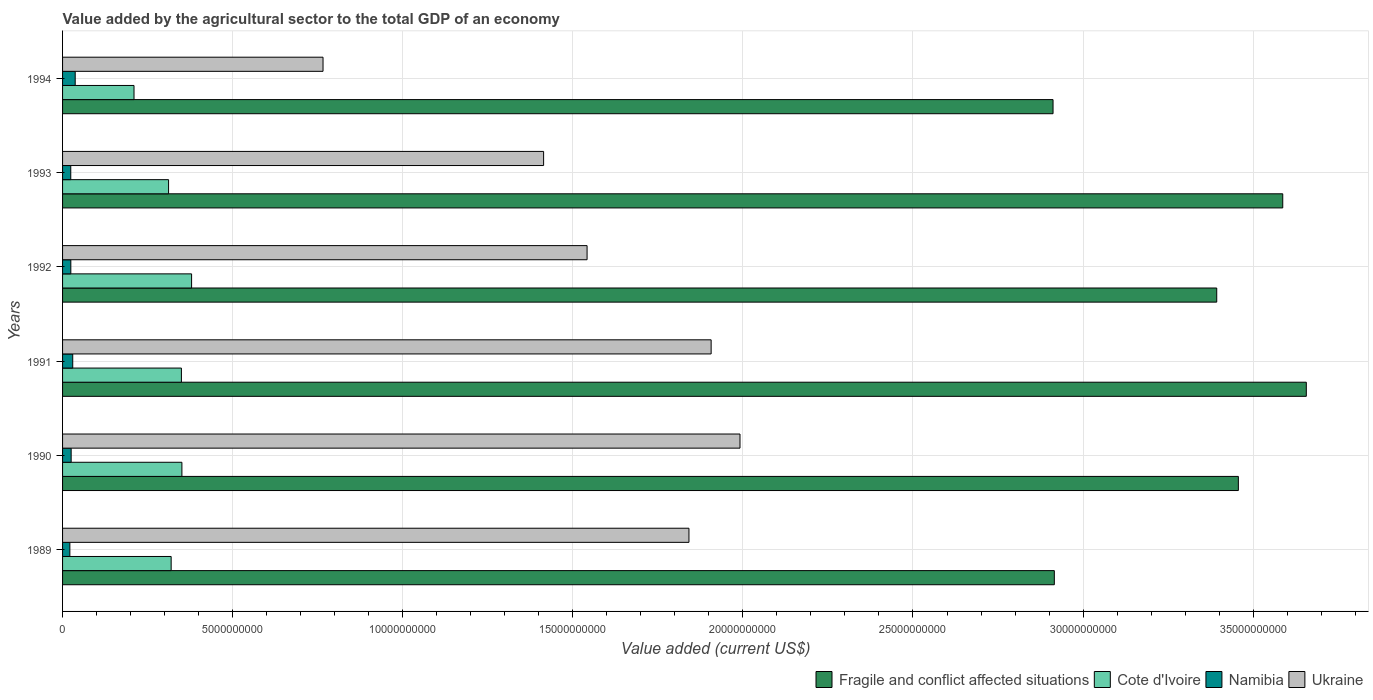How many different coloured bars are there?
Keep it short and to the point. 4. How many groups of bars are there?
Keep it short and to the point. 6. How many bars are there on the 4th tick from the top?
Your answer should be very brief. 4. In how many cases, is the number of bars for a given year not equal to the number of legend labels?
Offer a terse response. 0. What is the value added by the agricultural sector to the total GDP in Cote d'Ivoire in 1990?
Your answer should be very brief. 3.51e+09. Across all years, what is the maximum value added by the agricultural sector to the total GDP in Ukraine?
Give a very brief answer. 1.99e+1. Across all years, what is the minimum value added by the agricultural sector to the total GDP in Cote d'Ivoire?
Your answer should be very brief. 2.10e+09. What is the total value added by the agricultural sector to the total GDP in Fragile and conflict affected situations in the graph?
Give a very brief answer. 1.99e+11. What is the difference between the value added by the agricultural sector to the total GDP in Namibia in 1991 and that in 1992?
Give a very brief answer. 5.60e+07. What is the difference between the value added by the agricultural sector to the total GDP in Namibia in 1993 and the value added by the agricultural sector to the total GDP in Ukraine in 1989?
Give a very brief answer. -1.82e+1. What is the average value added by the agricultural sector to the total GDP in Ukraine per year?
Offer a terse response. 1.58e+1. In the year 1994, what is the difference between the value added by the agricultural sector to the total GDP in Cote d'Ivoire and value added by the agricultural sector to the total GDP in Namibia?
Your answer should be very brief. 1.73e+09. In how many years, is the value added by the agricultural sector to the total GDP in Ukraine greater than 11000000000 US$?
Make the answer very short. 5. What is the ratio of the value added by the agricultural sector to the total GDP in Cote d'Ivoire in 1990 to that in 1994?
Provide a succinct answer. 1.67. Is the value added by the agricultural sector to the total GDP in Cote d'Ivoire in 1989 less than that in 1994?
Your answer should be very brief. No. Is the difference between the value added by the agricultural sector to the total GDP in Cote d'Ivoire in 1991 and 1994 greater than the difference between the value added by the agricultural sector to the total GDP in Namibia in 1991 and 1994?
Provide a succinct answer. Yes. What is the difference between the highest and the second highest value added by the agricultural sector to the total GDP in Cote d'Ivoire?
Your answer should be very brief. 2.85e+08. What is the difference between the highest and the lowest value added by the agricultural sector to the total GDP in Cote d'Ivoire?
Provide a succinct answer. 1.69e+09. In how many years, is the value added by the agricultural sector to the total GDP in Cote d'Ivoire greater than the average value added by the agricultural sector to the total GDP in Cote d'Ivoire taken over all years?
Provide a succinct answer. 3. Is it the case that in every year, the sum of the value added by the agricultural sector to the total GDP in Cote d'Ivoire and value added by the agricultural sector to the total GDP in Namibia is greater than the sum of value added by the agricultural sector to the total GDP in Ukraine and value added by the agricultural sector to the total GDP in Fragile and conflict affected situations?
Keep it short and to the point. Yes. What does the 4th bar from the top in 1989 represents?
Keep it short and to the point. Fragile and conflict affected situations. What does the 2nd bar from the bottom in 1989 represents?
Provide a succinct answer. Cote d'Ivoire. What is the difference between two consecutive major ticks on the X-axis?
Keep it short and to the point. 5.00e+09. Are the values on the major ticks of X-axis written in scientific E-notation?
Make the answer very short. No. Does the graph contain grids?
Offer a terse response. Yes. Where does the legend appear in the graph?
Make the answer very short. Bottom right. How are the legend labels stacked?
Your answer should be very brief. Horizontal. What is the title of the graph?
Provide a succinct answer. Value added by the agricultural sector to the total GDP of an economy. What is the label or title of the X-axis?
Your response must be concise. Value added (current US$). What is the Value added (current US$) in Fragile and conflict affected situations in 1989?
Offer a terse response. 2.92e+1. What is the Value added (current US$) of Cote d'Ivoire in 1989?
Your answer should be compact. 3.19e+09. What is the Value added (current US$) of Namibia in 1989?
Your answer should be very brief. 2.14e+08. What is the Value added (current US$) of Ukraine in 1989?
Your response must be concise. 1.84e+1. What is the Value added (current US$) in Fragile and conflict affected situations in 1990?
Make the answer very short. 3.46e+1. What is the Value added (current US$) of Cote d'Ivoire in 1990?
Provide a succinct answer. 3.51e+09. What is the Value added (current US$) of Namibia in 1990?
Offer a very short reply. 2.53e+08. What is the Value added (current US$) of Ukraine in 1990?
Ensure brevity in your answer.  1.99e+1. What is the Value added (current US$) of Fragile and conflict affected situations in 1991?
Provide a short and direct response. 3.66e+1. What is the Value added (current US$) in Cote d'Ivoire in 1991?
Offer a terse response. 3.49e+09. What is the Value added (current US$) in Namibia in 1991?
Offer a very short reply. 2.99e+08. What is the Value added (current US$) in Ukraine in 1991?
Offer a very short reply. 1.91e+1. What is the Value added (current US$) in Fragile and conflict affected situations in 1992?
Provide a short and direct response. 3.39e+1. What is the Value added (current US$) in Cote d'Ivoire in 1992?
Your answer should be compact. 3.79e+09. What is the Value added (current US$) of Namibia in 1992?
Offer a terse response. 2.43e+08. What is the Value added (current US$) of Ukraine in 1992?
Offer a very short reply. 1.54e+1. What is the Value added (current US$) of Fragile and conflict affected situations in 1993?
Give a very brief answer. 3.59e+1. What is the Value added (current US$) in Cote d'Ivoire in 1993?
Give a very brief answer. 3.12e+09. What is the Value added (current US$) of Namibia in 1993?
Offer a very short reply. 2.41e+08. What is the Value added (current US$) of Ukraine in 1993?
Provide a succinct answer. 1.41e+1. What is the Value added (current US$) of Fragile and conflict affected situations in 1994?
Provide a short and direct response. 2.91e+1. What is the Value added (current US$) of Cote d'Ivoire in 1994?
Give a very brief answer. 2.10e+09. What is the Value added (current US$) of Namibia in 1994?
Ensure brevity in your answer.  3.71e+08. What is the Value added (current US$) of Ukraine in 1994?
Offer a very short reply. 7.66e+09. Across all years, what is the maximum Value added (current US$) in Fragile and conflict affected situations?
Provide a succinct answer. 3.66e+1. Across all years, what is the maximum Value added (current US$) of Cote d'Ivoire?
Offer a very short reply. 3.79e+09. Across all years, what is the maximum Value added (current US$) of Namibia?
Offer a very short reply. 3.71e+08. Across all years, what is the maximum Value added (current US$) in Ukraine?
Your answer should be very brief. 1.99e+1. Across all years, what is the minimum Value added (current US$) of Fragile and conflict affected situations?
Your response must be concise. 2.91e+1. Across all years, what is the minimum Value added (current US$) in Cote d'Ivoire?
Provide a short and direct response. 2.10e+09. Across all years, what is the minimum Value added (current US$) in Namibia?
Give a very brief answer. 2.14e+08. Across all years, what is the minimum Value added (current US$) in Ukraine?
Make the answer very short. 7.66e+09. What is the total Value added (current US$) in Fragile and conflict affected situations in the graph?
Give a very brief answer. 1.99e+11. What is the total Value added (current US$) of Cote d'Ivoire in the graph?
Your answer should be very brief. 1.92e+1. What is the total Value added (current US$) in Namibia in the graph?
Your answer should be compact. 1.62e+09. What is the total Value added (current US$) in Ukraine in the graph?
Ensure brevity in your answer.  9.46e+1. What is the difference between the Value added (current US$) in Fragile and conflict affected situations in 1989 and that in 1990?
Your response must be concise. -5.41e+09. What is the difference between the Value added (current US$) of Cote d'Ivoire in 1989 and that in 1990?
Keep it short and to the point. -3.16e+08. What is the difference between the Value added (current US$) of Namibia in 1989 and that in 1990?
Your answer should be very brief. -3.82e+07. What is the difference between the Value added (current US$) in Ukraine in 1989 and that in 1990?
Give a very brief answer. -1.50e+09. What is the difference between the Value added (current US$) in Fragile and conflict affected situations in 1989 and that in 1991?
Your answer should be compact. -7.41e+09. What is the difference between the Value added (current US$) of Cote d'Ivoire in 1989 and that in 1991?
Your answer should be very brief. -3.01e+08. What is the difference between the Value added (current US$) of Namibia in 1989 and that in 1991?
Provide a short and direct response. -8.45e+07. What is the difference between the Value added (current US$) of Ukraine in 1989 and that in 1991?
Your response must be concise. -6.52e+08. What is the difference between the Value added (current US$) of Fragile and conflict affected situations in 1989 and that in 1992?
Make the answer very short. -4.77e+09. What is the difference between the Value added (current US$) in Cote d'Ivoire in 1989 and that in 1992?
Keep it short and to the point. -6.01e+08. What is the difference between the Value added (current US$) of Namibia in 1989 and that in 1992?
Your response must be concise. -2.85e+07. What is the difference between the Value added (current US$) of Ukraine in 1989 and that in 1992?
Provide a short and direct response. 2.99e+09. What is the difference between the Value added (current US$) in Fragile and conflict affected situations in 1989 and that in 1993?
Keep it short and to the point. -6.71e+09. What is the difference between the Value added (current US$) in Cote d'Ivoire in 1989 and that in 1993?
Your response must be concise. 7.57e+07. What is the difference between the Value added (current US$) of Namibia in 1989 and that in 1993?
Provide a succinct answer. -2.68e+07. What is the difference between the Value added (current US$) in Ukraine in 1989 and that in 1993?
Offer a terse response. 4.27e+09. What is the difference between the Value added (current US$) of Fragile and conflict affected situations in 1989 and that in 1994?
Make the answer very short. 3.81e+07. What is the difference between the Value added (current US$) of Cote d'Ivoire in 1989 and that in 1994?
Offer a very short reply. 1.09e+09. What is the difference between the Value added (current US$) of Namibia in 1989 and that in 1994?
Provide a succinct answer. -1.57e+08. What is the difference between the Value added (current US$) in Ukraine in 1989 and that in 1994?
Ensure brevity in your answer.  1.08e+1. What is the difference between the Value added (current US$) in Fragile and conflict affected situations in 1990 and that in 1991?
Your answer should be very brief. -2.00e+09. What is the difference between the Value added (current US$) of Cote d'Ivoire in 1990 and that in 1991?
Your answer should be compact. 1.51e+07. What is the difference between the Value added (current US$) of Namibia in 1990 and that in 1991?
Offer a very short reply. -4.63e+07. What is the difference between the Value added (current US$) of Ukraine in 1990 and that in 1991?
Keep it short and to the point. 8.49e+08. What is the difference between the Value added (current US$) of Fragile and conflict affected situations in 1990 and that in 1992?
Ensure brevity in your answer.  6.36e+08. What is the difference between the Value added (current US$) in Cote d'Ivoire in 1990 and that in 1992?
Provide a short and direct response. -2.85e+08. What is the difference between the Value added (current US$) in Namibia in 1990 and that in 1992?
Your answer should be very brief. 9.72e+06. What is the difference between the Value added (current US$) of Ukraine in 1990 and that in 1992?
Offer a terse response. 4.50e+09. What is the difference between the Value added (current US$) of Fragile and conflict affected situations in 1990 and that in 1993?
Offer a terse response. -1.31e+09. What is the difference between the Value added (current US$) of Cote d'Ivoire in 1990 and that in 1993?
Give a very brief answer. 3.92e+08. What is the difference between the Value added (current US$) of Namibia in 1990 and that in 1993?
Your answer should be very brief. 1.14e+07. What is the difference between the Value added (current US$) in Ukraine in 1990 and that in 1993?
Provide a succinct answer. 5.77e+09. What is the difference between the Value added (current US$) in Fragile and conflict affected situations in 1990 and that in 1994?
Give a very brief answer. 5.45e+09. What is the difference between the Value added (current US$) in Cote d'Ivoire in 1990 and that in 1994?
Keep it short and to the point. 1.41e+09. What is the difference between the Value added (current US$) in Namibia in 1990 and that in 1994?
Your answer should be compact. -1.19e+08. What is the difference between the Value added (current US$) in Ukraine in 1990 and that in 1994?
Provide a short and direct response. 1.23e+1. What is the difference between the Value added (current US$) in Fragile and conflict affected situations in 1991 and that in 1992?
Provide a short and direct response. 2.63e+09. What is the difference between the Value added (current US$) of Cote d'Ivoire in 1991 and that in 1992?
Your answer should be very brief. -3.00e+08. What is the difference between the Value added (current US$) in Namibia in 1991 and that in 1992?
Your answer should be very brief. 5.60e+07. What is the difference between the Value added (current US$) of Ukraine in 1991 and that in 1992?
Give a very brief answer. 3.65e+09. What is the difference between the Value added (current US$) in Fragile and conflict affected situations in 1991 and that in 1993?
Your answer should be very brief. 6.92e+08. What is the difference between the Value added (current US$) of Cote d'Ivoire in 1991 and that in 1993?
Make the answer very short. 3.77e+08. What is the difference between the Value added (current US$) of Namibia in 1991 and that in 1993?
Offer a terse response. 5.76e+07. What is the difference between the Value added (current US$) of Ukraine in 1991 and that in 1993?
Give a very brief answer. 4.92e+09. What is the difference between the Value added (current US$) of Fragile and conflict affected situations in 1991 and that in 1994?
Your answer should be very brief. 7.45e+09. What is the difference between the Value added (current US$) of Cote d'Ivoire in 1991 and that in 1994?
Offer a terse response. 1.39e+09. What is the difference between the Value added (current US$) in Namibia in 1991 and that in 1994?
Provide a short and direct response. -7.25e+07. What is the difference between the Value added (current US$) in Ukraine in 1991 and that in 1994?
Offer a terse response. 1.14e+1. What is the difference between the Value added (current US$) of Fragile and conflict affected situations in 1992 and that in 1993?
Keep it short and to the point. -1.94e+09. What is the difference between the Value added (current US$) in Cote d'Ivoire in 1992 and that in 1993?
Keep it short and to the point. 6.77e+08. What is the difference between the Value added (current US$) of Namibia in 1992 and that in 1993?
Provide a succinct answer. 1.67e+06. What is the difference between the Value added (current US$) in Ukraine in 1992 and that in 1993?
Your answer should be very brief. 1.28e+09. What is the difference between the Value added (current US$) in Fragile and conflict affected situations in 1992 and that in 1994?
Provide a short and direct response. 4.81e+09. What is the difference between the Value added (current US$) of Cote d'Ivoire in 1992 and that in 1994?
Your answer should be compact. 1.69e+09. What is the difference between the Value added (current US$) in Namibia in 1992 and that in 1994?
Make the answer very short. -1.28e+08. What is the difference between the Value added (current US$) of Ukraine in 1992 and that in 1994?
Offer a terse response. 7.76e+09. What is the difference between the Value added (current US$) in Fragile and conflict affected situations in 1993 and that in 1994?
Provide a short and direct response. 6.75e+09. What is the difference between the Value added (current US$) in Cote d'Ivoire in 1993 and that in 1994?
Give a very brief answer. 1.02e+09. What is the difference between the Value added (current US$) of Namibia in 1993 and that in 1994?
Your answer should be very brief. -1.30e+08. What is the difference between the Value added (current US$) in Ukraine in 1993 and that in 1994?
Provide a succinct answer. 6.48e+09. What is the difference between the Value added (current US$) in Fragile and conflict affected situations in 1989 and the Value added (current US$) in Cote d'Ivoire in 1990?
Give a very brief answer. 2.56e+1. What is the difference between the Value added (current US$) in Fragile and conflict affected situations in 1989 and the Value added (current US$) in Namibia in 1990?
Your answer should be very brief. 2.89e+1. What is the difference between the Value added (current US$) in Fragile and conflict affected situations in 1989 and the Value added (current US$) in Ukraine in 1990?
Keep it short and to the point. 9.24e+09. What is the difference between the Value added (current US$) in Cote d'Ivoire in 1989 and the Value added (current US$) in Namibia in 1990?
Ensure brevity in your answer.  2.94e+09. What is the difference between the Value added (current US$) in Cote d'Ivoire in 1989 and the Value added (current US$) in Ukraine in 1990?
Your response must be concise. -1.67e+1. What is the difference between the Value added (current US$) in Namibia in 1989 and the Value added (current US$) in Ukraine in 1990?
Offer a terse response. -1.97e+1. What is the difference between the Value added (current US$) of Fragile and conflict affected situations in 1989 and the Value added (current US$) of Cote d'Ivoire in 1991?
Ensure brevity in your answer.  2.57e+1. What is the difference between the Value added (current US$) in Fragile and conflict affected situations in 1989 and the Value added (current US$) in Namibia in 1991?
Keep it short and to the point. 2.89e+1. What is the difference between the Value added (current US$) in Fragile and conflict affected situations in 1989 and the Value added (current US$) in Ukraine in 1991?
Keep it short and to the point. 1.01e+1. What is the difference between the Value added (current US$) in Cote d'Ivoire in 1989 and the Value added (current US$) in Namibia in 1991?
Provide a succinct answer. 2.89e+09. What is the difference between the Value added (current US$) of Cote d'Ivoire in 1989 and the Value added (current US$) of Ukraine in 1991?
Give a very brief answer. -1.59e+1. What is the difference between the Value added (current US$) of Namibia in 1989 and the Value added (current US$) of Ukraine in 1991?
Offer a very short reply. -1.89e+1. What is the difference between the Value added (current US$) of Fragile and conflict affected situations in 1989 and the Value added (current US$) of Cote d'Ivoire in 1992?
Provide a succinct answer. 2.54e+1. What is the difference between the Value added (current US$) in Fragile and conflict affected situations in 1989 and the Value added (current US$) in Namibia in 1992?
Your answer should be very brief. 2.89e+1. What is the difference between the Value added (current US$) of Fragile and conflict affected situations in 1989 and the Value added (current US$) of Ukraine in 1992?
Your answer should be compact. 1.37e+1. What is the difference between the Value added (current US$) of Cote d'Ivoire in 1989 and the Value added (current US$) of Namibia in 1992?
Your answer should be very brief. 2.95e+09. What is the difference between the Value added (current US$) in Cote d'Ivoire in 1989 and the Value added (current US$) in Ukraine in 1992?
Ensure brevity in your answer.  -1.22e+1. What is the difference between the Value added (current US$) in Namibia in 1989 and the Value added (current US$) in Ukraine in 1992?
Your answer should be very brief. -1.52e+1. What is the difference between the Value added (current US$) in Fragile and conflict affected situations in 1989 and the Value added (current US$) in Cote d'Ivoire in 1993?
Give a very brief answer. 2.60e+1. What is the difference between the Value added (current US$) in Fragile and conflict affected situations in 1989 and the Value added (current US$) in Namibia in 1993?
Give a very brief answer. 2.89e+1. What is the difference between the Value added (current US$) in Fragile and conflict affected situations in 1989 and the Value added (current US$) in Ukraine in 1993?
Your answer should be very brief. 1.50e+1. What is the difference between the Value added (current US$) of Cote d'Ivoire in 1989 and the Value added (current US$) of Namibia in 1993?
Your answer should be very brief. 2.95e+09. What is the difference between the Value added (current US$) of Cote d'Ivoire in 1989 and the Value added (current US$) of Ukraine in 1993?
Provide a short and direct response. -1.09e+1. What is the difference between the Value added (current US$) of Namibia in 1989 and the Value added (current US$) of Ukraine in 1993?
Keep it short and to the point. -1.39e+1. What is the difference between the Value added (current US$) of Fragile and conflict affected situations in 1989 and the Value added (current US$) of Cote d'Ivoire in 1994?
Give a very brief answer. 2.71e+1. What is the difference between the Value added (current US$) of Fragile and conflict affected situations in 1989 and the Value added (current US$) of Namibia in 1994?
Offer a very short reply. 2.88e+1. What is the difference between the Value added (current US$) in Fragile and conflict affected situations in 1989 and the Value added (current US$) in Ukraine in 1994?
Provide a succinct answer. 2.15e+1. What is the difference between the Value added (current US$) in Cote d'Ivoire in 1989 and the Value added (current US$) in Namibia in 1994?
Offer a very short reply. 2.82e+09. What is the difference between the Value added (current US$) of Cote d'Ivoire in 1989 and the Value added (current US$) of Ukraine in 1994?
Your response must be concise. -4.46e+09. What is the difference between the Value added (current US$) in Namibia in 1989 and the Value added (current US$) in Ukraine in 1994?
Provide a short and direct response. -7.44e+09. What is the difference between the Value added (current US$) in Fragile and conflict affected situations in 1990 and the Value added (current US$) in Cote d'Ivoire in 1991?
Give a very brief answer. 3.11e+1. What is the difference between the Value added (current US$) of Fragile and conflict affected situations in 1990 and the Value added (current US$) of Namibia in 1991?
Offer a terse response. 3.43e+1. What is the difference between the Value added (current US$) in Fragile and conflict affected situations in 1990 and the Value added (current US$) in Ukraine in 1991?
Make the answer very short. 1.55e+1. What is the difference between the Value added (current US$) in Cote d'Ivoire in 1990 and the Value added (current US$) in Namibia in 1991?
Give a very brief answer. 3.21e+09. What is the difference between the Value added (current US$) of Cote d'Ivoire in 1990 and the Value added (current US$) of Ukraine in 1991?
Your response must be concise. -1.56e+1. What is the difference between the Value added (current US$) of Namibia in 1990 and the Value added (current US$) of Ukraine in 1991?
Provide a succinct answer. -1.88e+1. What is the difference between the Value added (current US$) of Fragile and conflict affected situations in 1990 and the Value added (current US$) of Cote d'Ivoire in 1992?
Keep it short and to the point. 3.08e+1. What is the difference between the Value added (current US$) in Fragile and conflict affected situations in 1990 and the Value added (current US$) in Namibia in 1992?
Your answer should be very brief. 3.43e+1. What is the difference between the Value added (current US$) of Fragile and conflict affected situations in 1990 and the Value added (current US$) of Ukraine in 1992?
Keep it short and to the point. 1.91e+1. What is the difference between the Value added (current US$) in Cote d'Ivoire in 1990 and the Value added (current US$) in Namibia in 1992?
Provide a succinct answer. 3.27e+09. What is the difference between the Value added (current US$) in Cote d'Ivoire in 1990 and the Value added (current US$) in Ukraine in 1992?
Provide a short and direct response. -1.19e+1. What is the difference between the Value added (current US$) of Namibia in 1990 and the Value added (current US$) of Ukraine in 1992?
Give a very brief answer. -1.52e+1. What is the difference between the Value added (current US$) in Fragile and conflict affected situations in 1990 and the Value added (current US$) in Cote d'Ivoire in 1993?
Give a very brief answer. 3.14e+1. What is the difference between the Value added (current US$) in Fragile and conflict affected situations in 1990 and the Value added (current US$) in Namibia in 1993?
Your answer should be very brief. 3.43e+1. What is the difference between the Value added (current US$) of Fragile and conflict affected situations in 1990 and the Value added (current US$) of Ukraine in 1993?
Keep it short and to the point. 2.04e+1. What is the difference between the Value added (current US$) of Cote d'Ivoire in 1990 and the Value added (current US$) of Namibia in 1993?
Give a very brief answer. 3.27e+09. What is the difference between the Value added (current US$) of Cote d'Ivoire in 1990 and the Value added (current US$) of Ukraine in 1993?
Ensure brevity in your answer.  -1.06e+1. What is the difference between the Value added (current US$) of Namibia in 1990 and the Value added (current US$) of Ukraine in 1993?
Your answer should be very brief. -1.39e+1. What is the difference between the Value added (current US$) in Fragile and conflict affected situations in 1990 and the Value added (current US$) in Cote d'Ivoire in 1994?
Your answer should be very brief. 3.25e+1. What is the difference between the Value added (current US$) in Fragile and conflict affected situations in 1990 and the Value added (current US$) in Namibia in 1994?
Your answer should be very brief. 3.42e+1. What is the difference between the Value added (current US$) of Fragile and conflict affected situations in 1990 and the Value added (current US$) of Ukraine in 1994?
Ensure brevity in your answer.  2.69e+1. What is the difference between the Value added (current US$) of Cote d'Ivoire in 1990 and the Value added (current US$) of Namibia in 1994?
Your response must be concise. 3.14e+09. What is the difference between the Value added (current US$) of Cote d'Ivoire in 1990 and the Value added (current US$) of Ukraine in 1994?
Provide a succinct answer. -4.15e+09. What is the difference between the Value added (current US$) of Namibia in 1990 and the Value added (current US$) of Ukraine in 1994?
Make the answer very short. -7.40e+09. What is the difference between the Value added (current US$) in Fragile and conflict affected situations in 1991 and the Value added (current US$) in Cote d'Ivoire in 1992?
Provide a succinct answer. 3.28e+1. What is the difference between the Value added (current US$) of Fragile and conflict affected situations in 1991 and the Value added (current US$) of Namibia in 1992?
Your response must be concise. 3.63e+1. What is the difference between the Value added (current US$) in Fragile and conflict affected situations in 1991 and the Value added (current US$) in Ukraine in 1992?
Keep it short and to the point. 2.11e+1. What is the difference between the Value added (current US$) of Cote d'Ivoire in 1991 and the Value added (current US$) of Namibia in 1992?
Your answer should be compact. 3.25e+09. What is the difference between the Value added (current US$) of Cote d'Ivoire in 1991 and the Value added (current US$) of Ukraine in 1992?
Offer a terse response. -1.19e+1. What is the difference between the Value added (current US$) of Namibia in 1991 and the Value added (current US$) of Ukraine in 1992?
Your answer should be compact. -1.51e+1. What is the difference between the Value added (current US$) of Fragile and conflict affected situations in 1991 and the Value added (current US$) of Cote d'Ivoire in 1993?
Your response must be concise. 3.34e+1. What is the difference between the Value added (current US$) in Fragile and conflict affected situations in 1991 and the Value added (current US$) in Namibia in 1993?
Your answer should be compact. 3.63e+1. What is the difference between the Value added (current US$) of Fragile and conflict affected situations in 1991 and the Value added (current US$) of Ukraine in 1993?
Offer a very short reply. 2.24e+1. What is the difference between the Value added (current US$) of Cote d'Ivoire in 1991 and the Value added (current US$) of Namibia in 1993?
Ensure brevity in your answer.  3.25e+09. What is the difference between the Value added (current US$) of Cote d'Ivoire in 1991 and the Value added (current US$) of Ukraine in 1993?
Ensure brevity in your answer.  -1.06e+1. What is the difference between the Value added (current US$) of Namibia in 1991 and the Value added (current US$) of Ukraine in 1993?
Offer a terse response. -1.38e+1. What is the difference between the Value added (current US$) of Fragile and conflict affected situations in 1991 and the Value added (current US$) of Cote d'Ivoire in 1994?
Make the answer very short. 3.45e+1. What is the difference between the Value added (current US$) of Fragile and conflict affected situations in 1991 and the Value added (current US$) of Namibia in 1994?
Ensure brevity in your answer.  3.62e+1. What is the difference between the Value added (current US$) in Fragile and conflict affected situations in 1991 and the Value added (current US$) in Ukraine in 1994?
Your answer should be compact. 2.89e+1. What is the difference between the Value added (current US$) in Cote d'Ivoire in 1991 and the Value added (current US$) in Namibia in 1994?
Make the answer very short. 3.12e+09. What is the difference between the Value added (current US$) of Cote d'Ivoire in 1991 and the Value added (current US$) of Ukraine in 1994?
Give a very brief answer. -4.16e+09. What is the difference between the Value added (current US$) in Namibia in 1991 and the Value added (current US$) in Ukraine in 1994?
Your answer should be very brief. -7.36e+09. What is the difference between the Value added (current US$) in Fragile and conflict affected situations in 1992 and the Value added (current US$) in Cote d'Ivoire in 1993?
Ensure brevity in your answer.  3.08e+1. What is the difference between the Value added (current US$) in Fragile and conflict affected situations in 1992 and the Value added (current US$) in Namibia in 1993?
Offer a very short reply. 3.37e+1. What is the difference between the Value added (current US$) of Fragile and conflict affected situations in 1992 and the Value added (current US$) of Ukraine in 1993?
Your answer should be very brief. 1.98e+1. What is the difference between the Value added (current US$) of Cote d'Ivoire in 1992 and the Value added (current US$) of Namibia in 1993?
Provide a succinct answer. 3.55e+09. What is the difference between the Value added (current US$) of Cote d'Ivoire in 1992 and the Value added (current US$) of Ukraine in 1993?
Offer a very short reply. -1.03e+1. What is the difference between the Value added (current US$) in Namibia in 1992 and the Value added (current US$) in Ukraine in 1993?
Your answer should be very brief. -1.39e+1. What is the difference between the Value added (current US$) in Fragile and conflict affected situations in 1992 and the Value added (current US$) in Cote d'Ivoire in 1994?
Provide a succinct answer. 3.18e+1. What is the difference between the Value added (current US$) in Fragile and conflict affected situations in 1992 and the Value added (current US$) in Namibia in 1994?
Ensure brevity in your answer.  3.36e+1. What is the difference between the Value added (current US$) in Fragile and conflict affected situations in 1992 and the Value added (current US$) in Ukraine in 1994?
Offer a very short reply. 2.63e+1. What is the difference between the Value added (current US$) of Cote d'Ivoire in 1992 and the Value added (current US$) of Namibia in 1994?
Your answer should be compact. 3.42e+09. What is the difference between the Value added (current US$) of Cote d'Ivoire in 1992 and the Value added (current US$) of Ukraine in 1994?
Ensure brevity in your answer.  -3.86e+09. What is the difference between the Value added (current US$) of Namibia in 1992 and the Value added (current US$) of Ukraine in 1994?
Offer a very short reply. -7.41e+09. What is the difference between the Value added (current US$) in Fragile and conflict affected situations in 1993 and the Value added (current US$) in Cote d'Ivoire in 1994?
Keep it short and to the point. 3.38e+1. What is the difference between the Value added (current US$) in Fragile and conflict affected situations in 1993 and the Value added (current US$) in Namibia in 1994?
Offer a very short reply. 3.55e+1. What is the difference between the Value added (current US$) in Fragile and conflict affected situations in 1993 and the Value added (current US$) in Ukraine in 1994?
Give a very brief answer. 2.82e+1. What is the difference between the Value added (current US$) of Cote d'Ivoire in 1993 and the Value added (current US$) of Namibia in 1994?
Your answer should be very brief. 2.75e+09. What is the difference between the Value added (current US$) in Cote d'Ivoire in 1993 and the Value added (current US$) in Ukraine in 1994?
Ensure brevity in your answer.  -4.54e+09. What is the difference between the Value added (current US$) of Namibia in 1993 and the Value added (current US$) of Ukraine in 1994?
Provide a succinct answer. -7.42e+09. What is the average Value added (current US$) in Fragile and conflict affected situations per year?
Keep it short and to the point. 3.32e+1. What is the average Value added (current US$) in Cote d'Ivoire per year?
Give a very brief answer. 3.20e+09. What is the average Value added (current US$) of Namibia per year?
Your response must be concise. 2.70e+08. What is the average Value added (current US$) of Ukraine per year?
Your response must be concise. 1.58e+1. In the year 1989, what is the difference between the Value added (current US$) of Fragile and conflict affected situations and Value added (current US$) of Cote d'Ivoire?
Your answer should be compact. 2.60e+1. In the year 1989, what is the difference between the Value added (current US$) in Fragile and conflict affected situations and Value added (current US$) in Namibia?
Your answer should be compact. 2.89e+1. In the year 1989, what is the difference between the Value added (current US$) of Fragile and conflict affected situations and Value added (current US$) of Ukraine?
Offer a very short reply. 1.07e+1. In the year 1989, what is the difference between the Value added (current US$) of Cote d'Ivoire and Value added (current US$) of Namibia?
Offer a terse response. 2.98e+09. In the year 1989, what is the difference between the Value added (current US$) of Cote d'Ivoire and Value added (current US$) of Ukraine?
Ensure brevity in your answer.  -1.52e+1. In the year 1989, what is the difference between the Value added (current US$) in Namibia and Value added (current US$) in Ukraine?
Your response must be concise. -1.82e+1. In the year 1990, what is the difference between the Value added (current US$) in Fragile and conflict affected situations and Value added (current US$) in Cote d'Ivoire?
Keep it short and to the point. 3.11e+1. In the year 1990, what is the difference between the Value added (current US$) in Fragile and conflict affected situations and Value added (current US$) in Namibia?
Your answer should be very brief. 3.43e+1. In the year 1990, what is the difference between the Value added (current US$) in Fragile and conflict affected situations and Value added (current US$) in Ukraine?
Offer a very short reply. 1.47e+1. In the year 1990, what is the difference between the Value added (current US$) of Cote d'Ivoire and Value added (current US$) of Namibia?
Keep it short and to the point. 3.26e+09. In the year 1990, what is the difference between the Value added (current US$) in Cote d'Ivoire and Value added (current US$) in Ukraine?
Ensure brevity in your answer.  -1.64e+1. In the year 1990, what is the difference between the Value added (current US$) of Namibia and Value added (current US$) of Ukraine?
Provide a short and direct response. -1.97e+1. In the year 1991, what is the difference between the Value added (current US$) in Fragile and conflict affected situations and Value added (current US$) in Cote d'Ivoire?
Offer a terse response. 3.31e+1. In the year 1991, what is the difference between the Value added (current US$) of Fragile and conflict affected situations and Value added (current US$) of Namibia?
Provide a short and direct response. 3.63e+1. In the year 1991, what is the difference between the Value added (current US$) of Fragile and conflict affected situations and Value added (current US$) of Ukraine?
Your answer should be compact. 1.75e+1. In the year 1991, what is the difference between the Value added (current US$) in Cote d'Ivoire and Value added (current US$) in Namibia?
Your answer should be very brief. 3.19e+09. In the year 1991, what is the difference between the Value added (current US$) in Cote d'Ivoire and Value added (current US$) in Ukraine?
Your answer should be very brief. -1.56e+1. In the year 1991, what is the difference between the Value added (current US$) of Namibia and Value added (current US$) of Ukraine?
Make the answer very short. -1.88e+1. In the year 1992, what is the difference between the Value added (current US$) in Fragile and conflict affected situations and Value added (current US$) in Cote d'Ivoire?
Provide a succinct answer. 3.01e+1. In the year 1992, what is the difference between the Value added (current US$) in Fragile and conflict affected situations and Value added (current US$) in Namibia?
Provide a succinct answer. 3.37e+1. In the year 1992, what is the difference between the Value added (current US$) of Fragile and conflict affected situations and Value added (current US$) of Ukraine?
Provide a short and direct response. 1.85e+1. In the year 1992, what is the difference between the Value added (current US$) of Cote d'Ivoire and Value added (current US$) of Namibia?
Your answer should be compact. 3.55e+09. In the year 1992, what is the difference between the Value added (current US$) of Cote d'Ivoire and Value added (current US$) of Ukraine?
Provide a succinct answer. -1.16e+1. In the year 1992, what is the difference between the Value added (current US$) in Namibia and Value added (current US$) in Ukraine?
Give a very brief answer. -1.52e+1. In the year 1993, what is the difference between the Value added (current US$) of Fragile and conflict affected situations and Value added (current US$) of Cote d'Ivoire?
Ensure brevity in your answer.  3.28e+1. In the year 1993, what is the difference between the Value added (current US$) in Fragile and conflict affected situations and Value added (current US$) in Namibia?
Ensure brevity in your answer.  3.56e+1. In the year 1993, what is the difference between the Value added (current US$) of Fragile and conflict affected situations and Value added (current US$) of Ukraine?
Give a very brief answer. 2.17e+1. In the year 1993, what is the difference between the Value added (current US$) in Cote d'Ivoire and Value added (current US$) in Namibia?
Your response must be concise. 2.88e+09. In the year 1993, what is the difference between the Value added (current US$) in Cote d'Ivoire and Value added (current US$) in Ukraine?
Provide a succinct answer. -1.10e+1. In the year 1993, what is the difference between the Value added (current US$) of Namibia and Value added (current US$) of Ukraine?
Keep it short and to the point. -1.39e+1. In the year 1994, what is the difference between the Value added (current US$) in Fragile and conflict affected situations and Value added (current US$) in Cote d'Ivoire?
Your response must be concise. 2.70e+1. In the year 1994, what is the difference between the Value added (current US$) of Fragile and conflict affected situations and Value added (current US$) of Namibia?
Offer a terse response. 2.87e+1. In the year 1994, what is the difference between the Value added (current US$) of Fragile and conflict affected situations and Value added (current US$) of Ukraine?
Provide a short and direct response. 2.15e+1. In the year 1994, what is the difference between the Value added (current US$) in Cote d'Ivoire and Value added (current US$) in Namibia?
Your answer should be compact. 1.73e+09. In the year 1994, what is the difference between the Value added (current US$) of Cote d'Ivoire and Value added (current US$) of Ukraine?
Your answer should be very brief. -5.56e+09. In the year 1994, what is the difference between the Value added (current US$) of Namibia and Value added (current US$) of Ukraine?
Provide a short and direct response. -7.29e+09. What is the ratio of the Value added (current US$) in Fragile and conflict affected situations in 1989 to that in 1990?
Give a very brief answer. 0.84. What is the ratio of the Value added (current US$) of Cote d'Ivoire in 1989 to that in 1990?
Your answer should be very brief. 0.91. What is the ratio of the Value added (current US$) in Namibia in 1989 to that in 1990?
Provide a succinct answer. 0.85. What is the ratio of the Value added (current US$) in Ukraine in 1989 to that in 1990?
Give a very brief answer. 0.92. What is the ratio of the Value added (current US$) in Fragile and conflict affected situations in 1989 to that in 1991?
Your answer should be compact. 0.8. What is the ratio of the Value added (current US$) in Cote d'Ivoire in 1989 to that in 1991?
Give a very brief answer. 0.91. What is the ratio of the Value added (current US$) in Namibia in 1989 to that in 1991?
Offer a very short reply. 0.72. What is the ratio of the Value added (current US$) of Ukraine in 1989 to that in 1991?
Ensure brevity in your answer.  0.97. What is the ratio of the Value added (current US$) of Fragile and conflict affected situations in 1989 to that in 1992?
Provide a short and direct response. 0.86. What is the ratio of the Value added (current US$) of Cote d'Ivoire in 1989 to that in 1992?
Provide a succinct answer. 0.84. What is the ratio of the Value added (current US$) in Namibia in 1989 to that in 1992?
Your response must be concise. 0.88. What is the ratio of the Value added (current US$) in Ukraine in 1989 to that in 1992?
Keep it short and to the point. 1.19. What is the ratio of the Value added (current US$) in Fragile and conflict affected situations in 1989 to that in 1993?
Keep it short and to the point. 0.81. What is the ratio of the Value added (current US$) in Cote d'Ivoire in 1989 to that in 1993?
Your answer should be very brief. 1.02. What is the ratio of the Value added (current US$) in Namibia in 1989 to that in 1993?
Provide a short and direct response. 0.89. What is the ratio of the Value added (current US$) of Ukraine in 1989 to that in 1993?
Your answer should be compact. 1.3. What is the ratio of the Value added (current US$) in Cote d'Ivoire in 1989 to that in 1994?
Keep it short and to the point. 1.52. What is the ratio of the Value added (current US$) in Namibia in 1989 to that in 1994?
Give a very brief answer. 0.58. What is the ratio of the Value added (current US$) of Ukraine in 1989 to that in 1994?
Keep it short and to the point. 2.4. What is the ratio of the Value added (current US$) of Fragile and conflict affected situations in 1990 to that in 1991?
Your answer should be very brief. 0.95. What is the ratio of the Value added (current US$) of Namibia in 1990 to that in 1991?
Give a very brief answer. 0.85. What is the ratio of the Value added (current US$) in Ukraine in 1990 to that in 1991?
Your answer should be very brief. 1.04. What is the ratio of the Value added (current US$) in Fragile and conflict affected situations in 1990 to that in 1992?
Give a very brief answer. 1.02. What is the ratio of the Value added (current US$) of Cote d'Ivoire in 1990 to that in 1992?
Provide a short and direct response. 0.93. What is the ratio of the Value added (current US$) in Namibia in 1990 to that in 1992?
Offer a terse response. 1.04. What is the ratio of the Value added (current US$) of Ukraine in 1990 to that in 1992?
Ensure brevity in your answer.  1.29. What is the ratio of the Value added (current US$) of Fragile and conflict affected situations in 1990 to that in 1993?
Your answer should be compact. 0.96. What is the ratio of the Value added (current US$) in Cote d'Ivoire in 1990 to that in 1993?
Keep it short and to the point. 1.13. What is the ratio of the Value added (current US$) of Namibia in 1990 to that in 1993?
Your answer should be very brief. 1.05. What is the ratio of the Value added (current US$) of Ukraine in 1990 to that in 1993?
Provide a succinct answer. 1.41. What is the ratio of the Value added (current US$) in Fragile and conflict affected situations in 1990 to that in 1994?
Your answer should be compact. 1.19. What is the ratio of the Value added (current US$) in Cote d'Ivoire in 1990 to that in 1994?
Your answer should be very brief. 1.67. What is the ratio of the Value added (current US$) of Namibia in 1990 to that in 1994?
Make the answer very short. 0.68. What is the ratio of the Value added (current US$) in Ukraine in 1990 to that in 1994?
Your answer should be very brief. 2.6. What is the ratio of the Value added (current US$) of Fragile and conflict affected situations in 1991 to that in 1992?
Offer a very short reply. 1.08. What is the ratio of the Value added (current US$) of Cote d'Ivoire in 1991 to that in 1992?
Your response must be concise. 0.92. What is the ratio of the Value added (current US$) of Namibia in 1991 to that in 1992?
Ensure brevity in your answer.  1.23. What is the ratio of the Value added (current US$) of Ukraine in 1991 to that in 1992?
Give a very brief answer. 1.24. What is the ratio of the Value added (current US$) in Fragile and conflict affected situations in 1991 to that in 1993?
Keep it short and to the point. 1.02. What is the ratio of the Value added (current US$) in Cote d'Ivoire in 1991 to that in 1993?
Your answer should be compact. 1.12. What is the ratio of the Value added (current US$) in Namibia in 1991 to that in 1993?
Offer a terse response. 1.24. What is the ratio of the Value added (current US$) in Ukraine in 1991 to that in 1993?
Ensure brevity in your answer.  1.35. What is the ratio of the Value added (current US$) of Fragile and conflict affected situations in 1991 to that in 1994?
Offer a terse response. 1.26. What is the ratio of the Value added (current US$) in Cote d'Ivoire in 1991 to that in 1994?
Ensure brevity in your answer.  1.66. What is the ratio of the Value added (current US$) of Namibia in 1991 to that in 1994?
Offer a very short reply. 0.8. What is the ratio of the Value added (current US$) of Ukraine in 1991 to that in 1994?
Your response must be concise. 2.49. What is the ratio of the Value added (current US$) of Fragile and conflict affected situations in 1992 to that in 1993?
Your response must be concise. 0.95. What is the ratio of the Value added (current US$) in Cote d'Ivoire in 1992 to that in 1993?
Provide a short and direct response. 1.22. What is the ratio of the Value added (current US$) in Namibia in 1992 to that in 1993?
Offer a very short reply. 1.01. What is the ratio of the Value added (current US$) in Ukraine in 1992 to that in 1993?
Offer a very short reply. 1.09. What is the ratio of the Value added (current US$) of Fragile and conflict affected situations in 1992 to that in 1994?
Your answer should be very brief. 1.17. What is the ratio of the Value added (current US$) of Cote d'Ivoire in 1992 to that in 1994?
Offer a terse response. 1.81. What is the ratio of the Value added (current US$) of Namibia in 1992 to that in 1994?
Your answer should be very brief. 0.65. What is the ratio of the Value added (current US$) in Ukraine in 1992 to that in 1994?
Your answer should be very brief. 2.01. What is the ratio of the Value added (current US$) of Fragile and conflict affected situations in 1993 to that in 1994?
Provide a short and direct response. 1.23. What is the ratio of the Value added (current US$) of Cote d'Ivoire in 1993 to that in 1994?
Give a very brief answer. 1.48. What is the ratio of the Value added (current US$) of Namibia in 1993 to that in 1994?
Make the answer very short. 0.65. What is the ratio of the Value added (current US$) of Ukraine in 1993 to that in 1994?
Ensure brevity in your answer.  1.85. What is the difference between the highest and the second highest Value added (current US$) of Fragile and conflict affected situations?
Offer a very short reply. 6.92e+08. What is the difference between the highest and the second highest Value added (current US$) of Cote d'Ivoire?
Ensure brevity in your answer.  2.85e+08. What is the difference between the highest and the second highest Value added (current US$) in Namibia?
Your response must be concise. 7.25e+07. What is the difference between the highest and the second highest Value added (current US$) of Ukraine?
Provide a short and direct response. 8.49e+08. What is the difference between the highest and the lowest Value added (current US$) in Fragile and conflict affected situations?
Make the answer very short. 7.45e+09. What is the difference between the highest and the lowest Value added (current US$) in Cote d'Ivoire?
Keep it short and to the point. 1.69e+09. What is the difference between the highest and the lowest Value added (current US$) of Namibia?
Give a very brief answer. 1.57e+08. What is the difference between the highest and the lowest Value added (current US$) of Ukraine?
Offer a very short reply. 1.23e+1. 